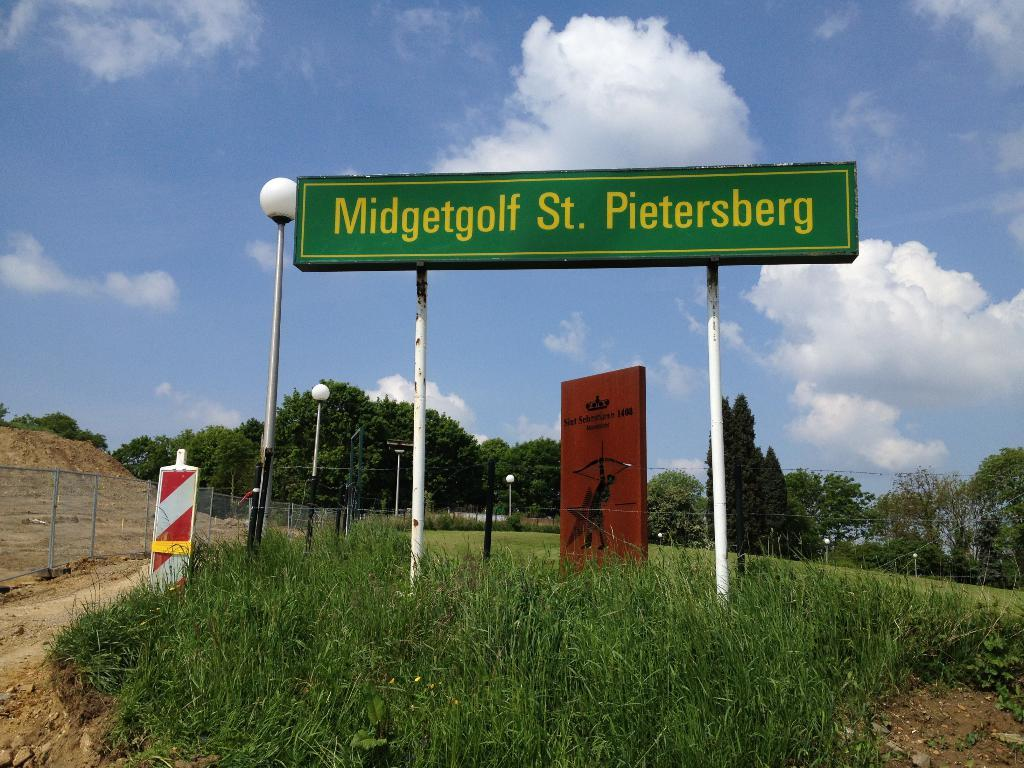Provide a one-sentence caption for the provided image. the name Pietersberg is on a green sign. 